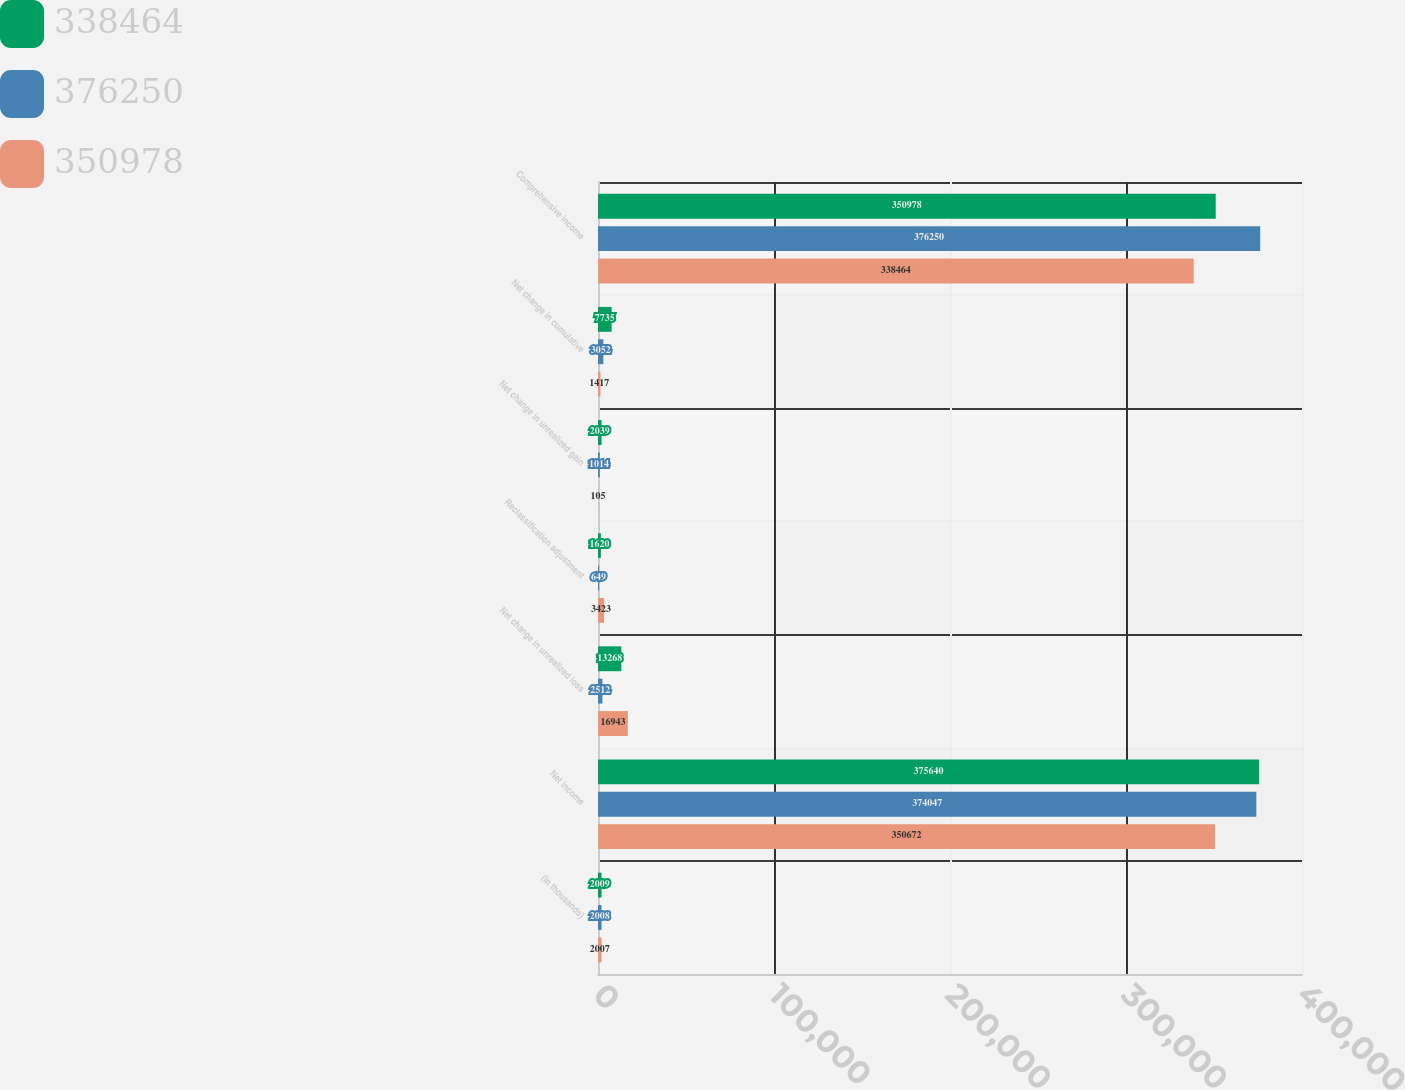Convert chart to OTSL. <chart><loc_0><loc_0><loc_500><loc_500><stacked_bar_chart><ecel><fcel>(In thousands)<fcel>Net income<fcel>Net change in unrealized loss<fcel>Reclassification adjustment<fcel>Net change in unrealized gain<fcel>Net change in cumulative<fcel>Comprehensive income<nl><fcel>338464<fcel>2009<fcel>375640<fcel>13268<fcel>1620<fcel>2039<fcel>7735<fcel>350978<nl><fcel>376250<fcel>2008<fcel>374047<fcel>2512<fcel>649<fcel>1014<fcel>3052<fcel>376250<nl><fcel>350978<fcel>2007<fcel>350672<fcel>16943<fcel>3423<fcel>105<fcel>1417<fcel>338464<nl></chart> 